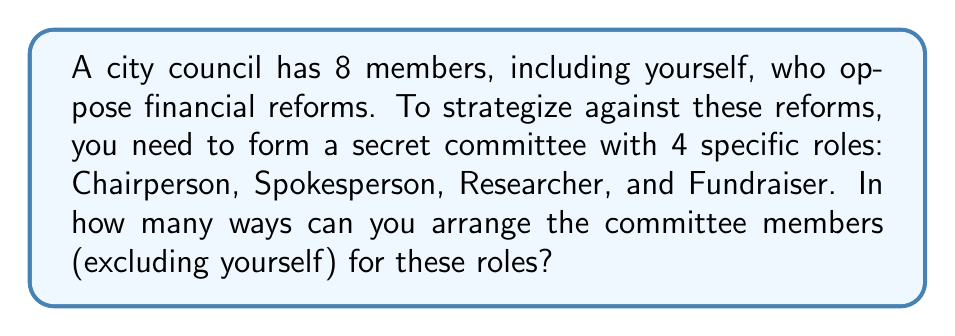Help me with this question. Let's approach this step-by-step:

1) First, we need to consider how many council members are available for the committee roles. Since there are 8 total members including yourself, and you're excluded from the committee, there are 7 members available.

2) We need to fill 4 distinct roles from these 7 members. This is a permutation problem, as the order matters (each role is different).

3) The formula for permutations is:

   $$P(n,r) = \frac{n!}{(n-r)!}$$

   Where $n$ is the total number of items to choose from, and $r$ is the number of items being chosen.

4) In this case, $n = 7$ (available members) and $r = 4$ (roles to fill).

5) Plugging these numbers into our formula:

   $$P(7,4) = \frac{7!}{(7-4)!} = \frac{7!}{3!}$$

6) Expanding this:

   $$\frac{7 * 6 * 5 * 4 * 3!}{3!}$$

7) The $3!$ cancels out in the numerator and denominator:

   $$7 * 6 * 5 * 4 = 840$$

Therefore, there are 840 ways to arrange the committee members for the different roles.
Answer: 840 